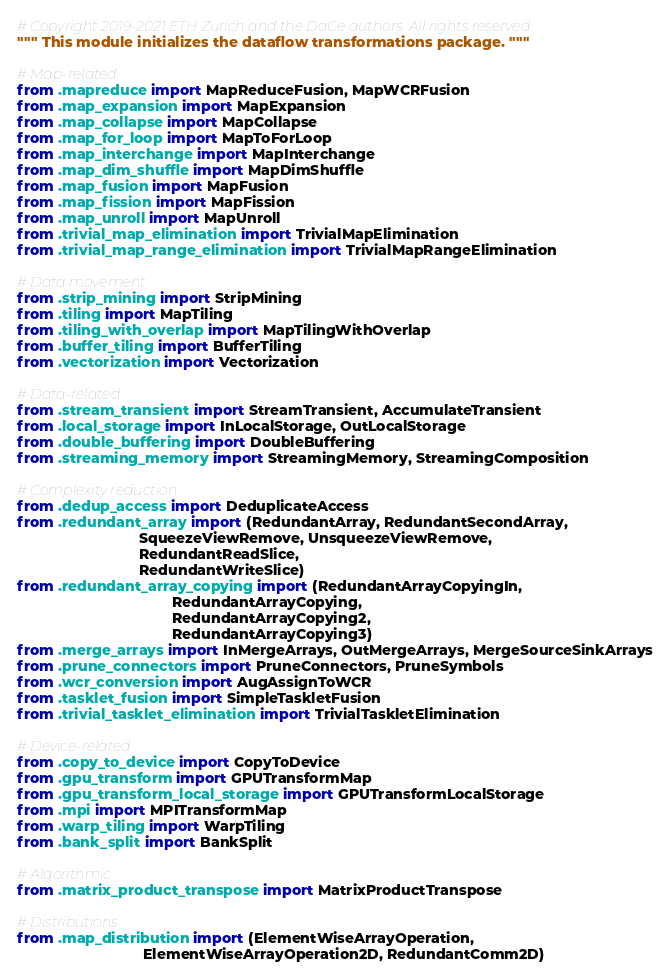Convert code to text. <code><loc_0><loc_0><loc_500><loc_500><_Python_># Copyright 2019-2021 ETH Zurich and the DaCe authors. All rights reserved.
""" This module initializes the dataflow transformations package. """

# Map-related
from .mapreduce import MapReduceFusion, MapWCRFusion
from .map_expansion import MapExpansion
from .map_collapse import MapCollapse
from .map_for_loop import MapToForLoop
from .map_interchange import MapInterchange
from .map_dim_shuffle import MapDimShuffle
from .map_fusion import MapFusion
from .map_fission import MapFission
from .map_unroll import MapUnroll
from .trivial_map_elimination import TrivialMapElimination
from .trivial_map_range_elimination import TrivialMapRangeElimination

# Data movement
from .strip_mining import StripMining
from .tiling import MapTiling
from .tiling_with_overlap import MapTilingWithOverlap
from .buffer_tiling import BufferTiling
from .vectorization import Vectorization

# Data-related
from .stream_transient import StreamTransient, AccumulateTransient
from .local_storage import InLocalStorage, OutLocalStorage
from .double_buffering import DoubleBuffering
from .streaming_memory import StreamingMemory, StreamingComposition

# Complexity reduction
from .dedup_access import DeduplicateAccess
from .redundant_array import (RedundantArray, RedundantSecondArray,
                              SqueezeViewRemove, UnsqueezeViewRemove,
                              RedundantReadSlice,
                              RedundantWriteSlice)
from .redundant_array_copying import (RedundantArrayCopyingIn,
                                      RedundantArrayCopying,
                                      RedundantArrayCopying2,
                                      RedundantArrayCopying3)
from .merge_arrays import InMergeArrays, OutMergeArrays, MergeSourceSinkArrays
from .prune_connectors import PruneConnectors, PruneSymbols
from .wcr_conversion import AugAssignToWCR
from .tasklet_fusion import SimpleTaskletFusion
from .trivial_tasklet_elimination import TrivialTaskletElimination

# Device-related
from .copy_to_device import CopyToDevice
from .gpu_transform import GPUTransformMap
from .gpu_transform_local_storage import GPUTransformLocalStorage
from .mpi import MPITransformMap
from .warp_tiling import WarpTiling
from .bank_split import BankSplit

# Algorithmic
from .matrix_product_transpose import MatrixProductTranspose

# Distributions
from .map_distribution import (ElementWiseArrayOperation,
                               ElementWiseArrayOperation2D, RedundantComm2D)
</code> 